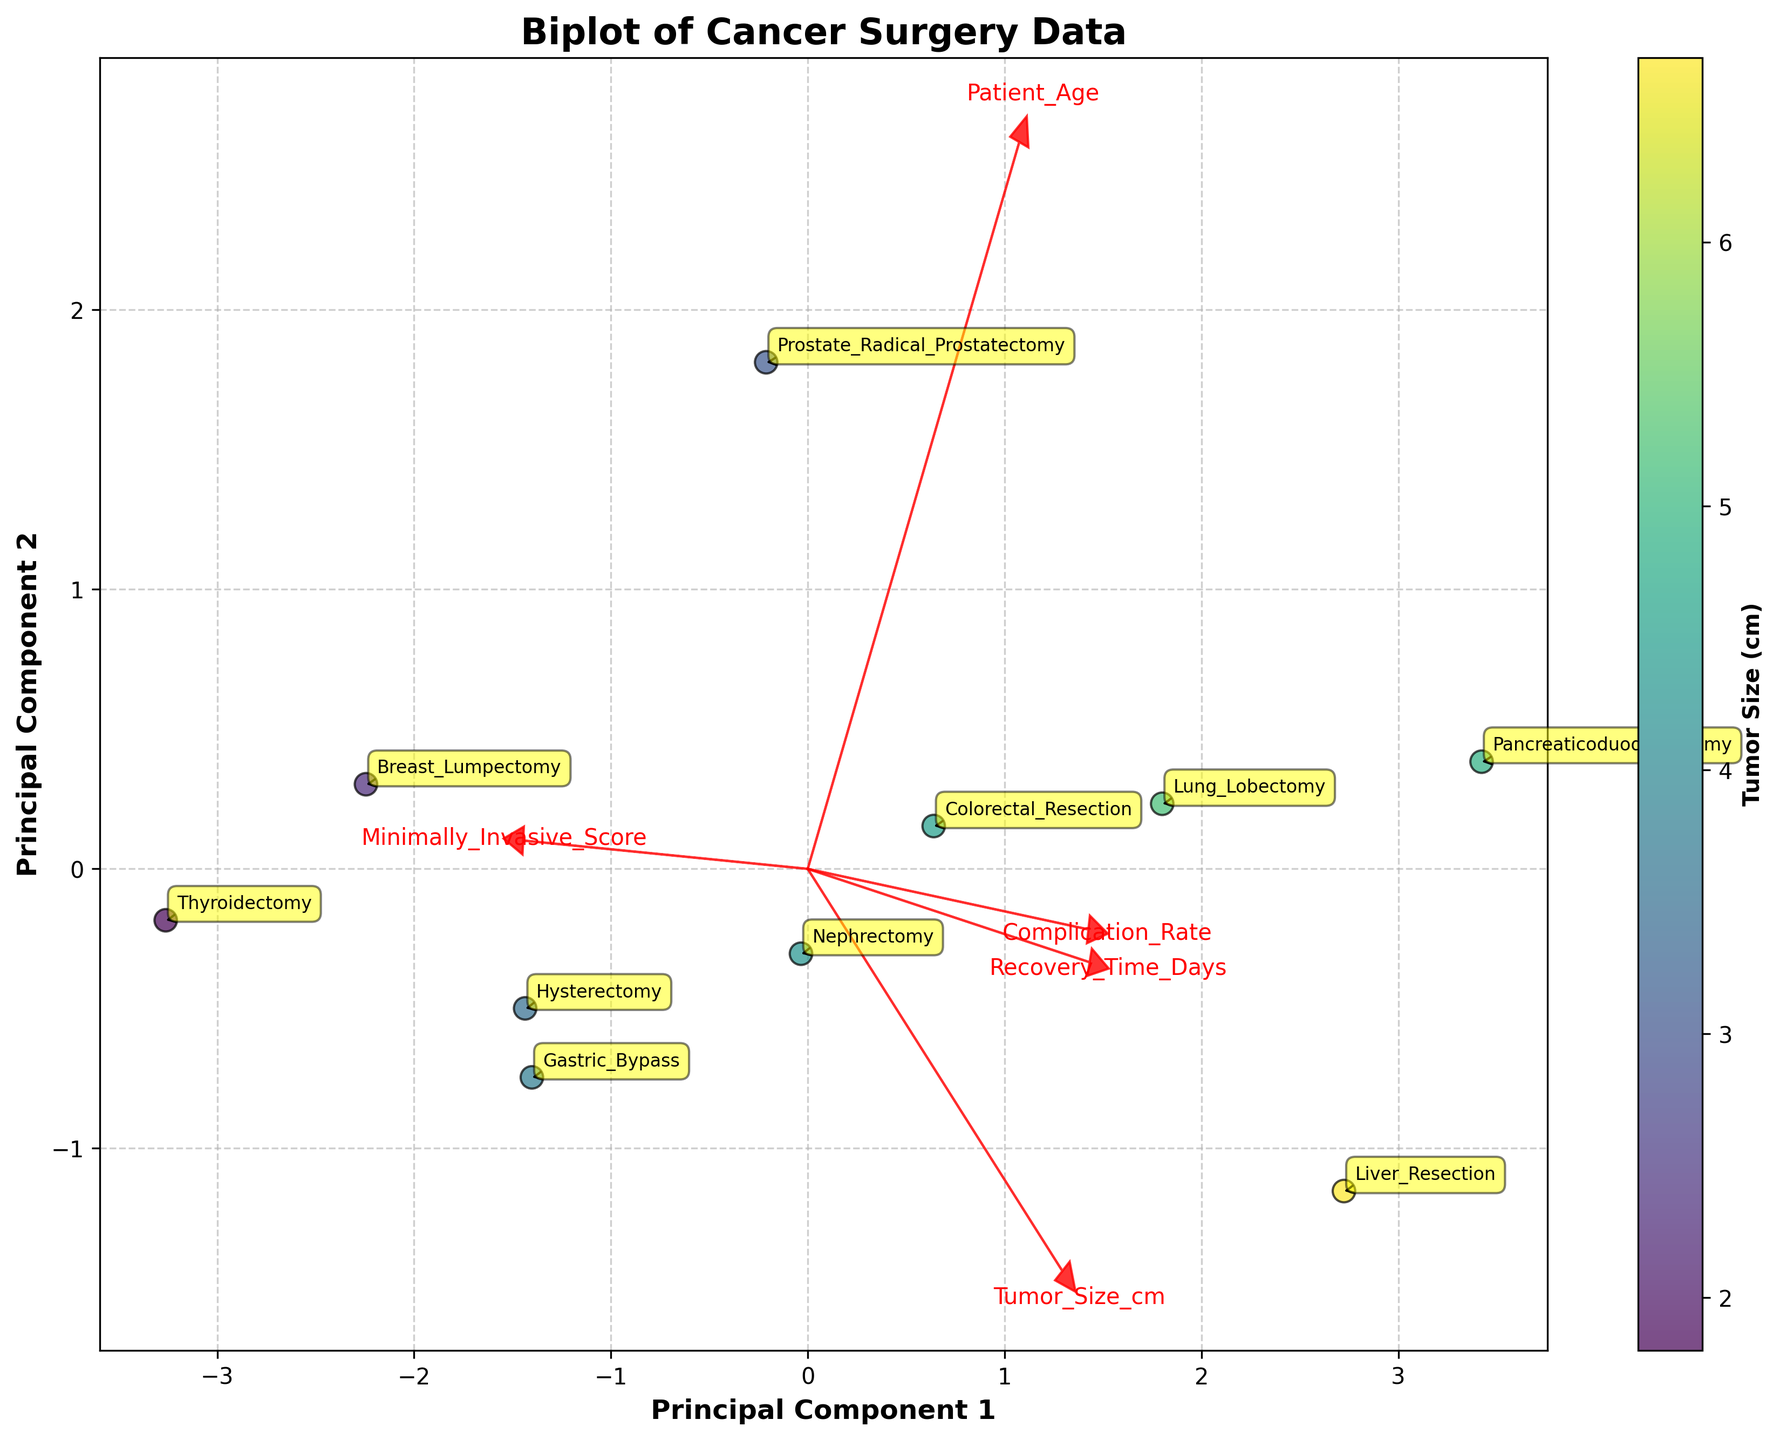What's the title of the figure? The title of the figure is prominently displayed at the top, making it easily identifiable.
Answer: Biplot of Cancer Surgery Data How many variables are represented by the vectors in the biplot? Each vector corresponds to a variable from the dataset, and counting them gives the total number of variables represented.
Answer: 5 Which variable seems to have the strongest influence on Principal Component 1 (PC1)? The variable with the longest arrow in the direction of PC1 suggests the strongest influence. Observing the biplot shows which arrow extends furthest along the PC1 axis.
Answer: Recovery_Time_Days Which surgery type has the highest score on Principal Component 2 (PC2)? Identify the data point with the highest PC2 value by observing the vertical position of each labeled point on the plot.
Answer: Pancreaticoduodenectomy Among Breast_Lumpectomy, Prostate_Radical_Prostatectomy, and Colorectal_Resection, which has the lowest score on Principal Component 1 (PC1)? Compare the positions of these three surgeries along the PC1 axis to determine which is positioned furthest to the left.
Answer: Colorectal_Resection What variable does the red arrow pointing most upwards represent? The specific direction of the red arrow indicates the variable that is most correlated with higher PC2 values. The upward pointing arrow can be identified and matched with the label closest to its tip.
Answer: Minimally_Invasive_Score Which surgery type has the lowest complication rate according to the data points' annotations? Look for the data point with the smallest annotation of complication rate. Cross-reference with the surgery type labels on the plot.
Answer: Thyroidectomy How does Tumor Size relate to the positioning in the biplot? The color gradient varies according to Tumor Size, helping to visualize how tumor size correlates with the principal components. Identify the general trend of color distribution.
Answer: Larger tumors tend to cluster on the left side of the plot Is there a surgery type that stands out as having both high recovery time and high complication rate? Examine the positions and labels, finding the data point that lies at high values of both PC1 and complication rate.
Answer: Pancreaticoduodenectomy What does the color of the data points represent in the biplot? The color bar next to the plot serves as a key for interpreting the variable represented by the colors of the points. Identify this variable.
Answer: Tumor Size (cm) 